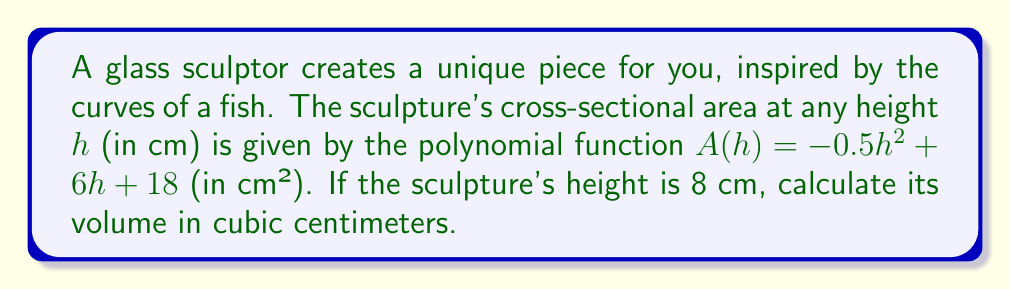Provide a solution to this math problem. To find the volume of the sculpture, we need to integrate the cross-sectional area function over the height of the sculpture. Here's how we do it:

1) The volume of a solid with a variable cross-sectional area is given by the definite integral:

   $$V = \int_{0}^{H} A(h) \, dh$$

   where $H$ is the height of the sculpture.

2) We're given $A(h) = -0.5h^2 + 6h + 18$ and $H = 8$ cm.

3) Let's set up the integral:

   $$V = \int_{0}^{8} (-0.5h^2 + 6h + 18) \, dh$$

4) Integrate each term:

   $$V = \left[-\frac{1}{6}h^3 + 3h^2 + 18h\right]_{0}^{8}$$

5) Evaluate at the upper and lower bounds:

   $$V = \left(-\frac{1}{6}(8^3) + 3(8^2) + 18(8)\right) - \left(-\frac{1}{6}(0^3) + 3(0^2) + 18(0)\right)$$

6) Simplify:

   $$V = (-42.67 + 192 + 144) - (0)$$
   $$V = 293.33$$

7) Round to two decimal places:

   $$V \approx 293.33 \text{ cm}^3$$
Answer: 293.33 cm³ 